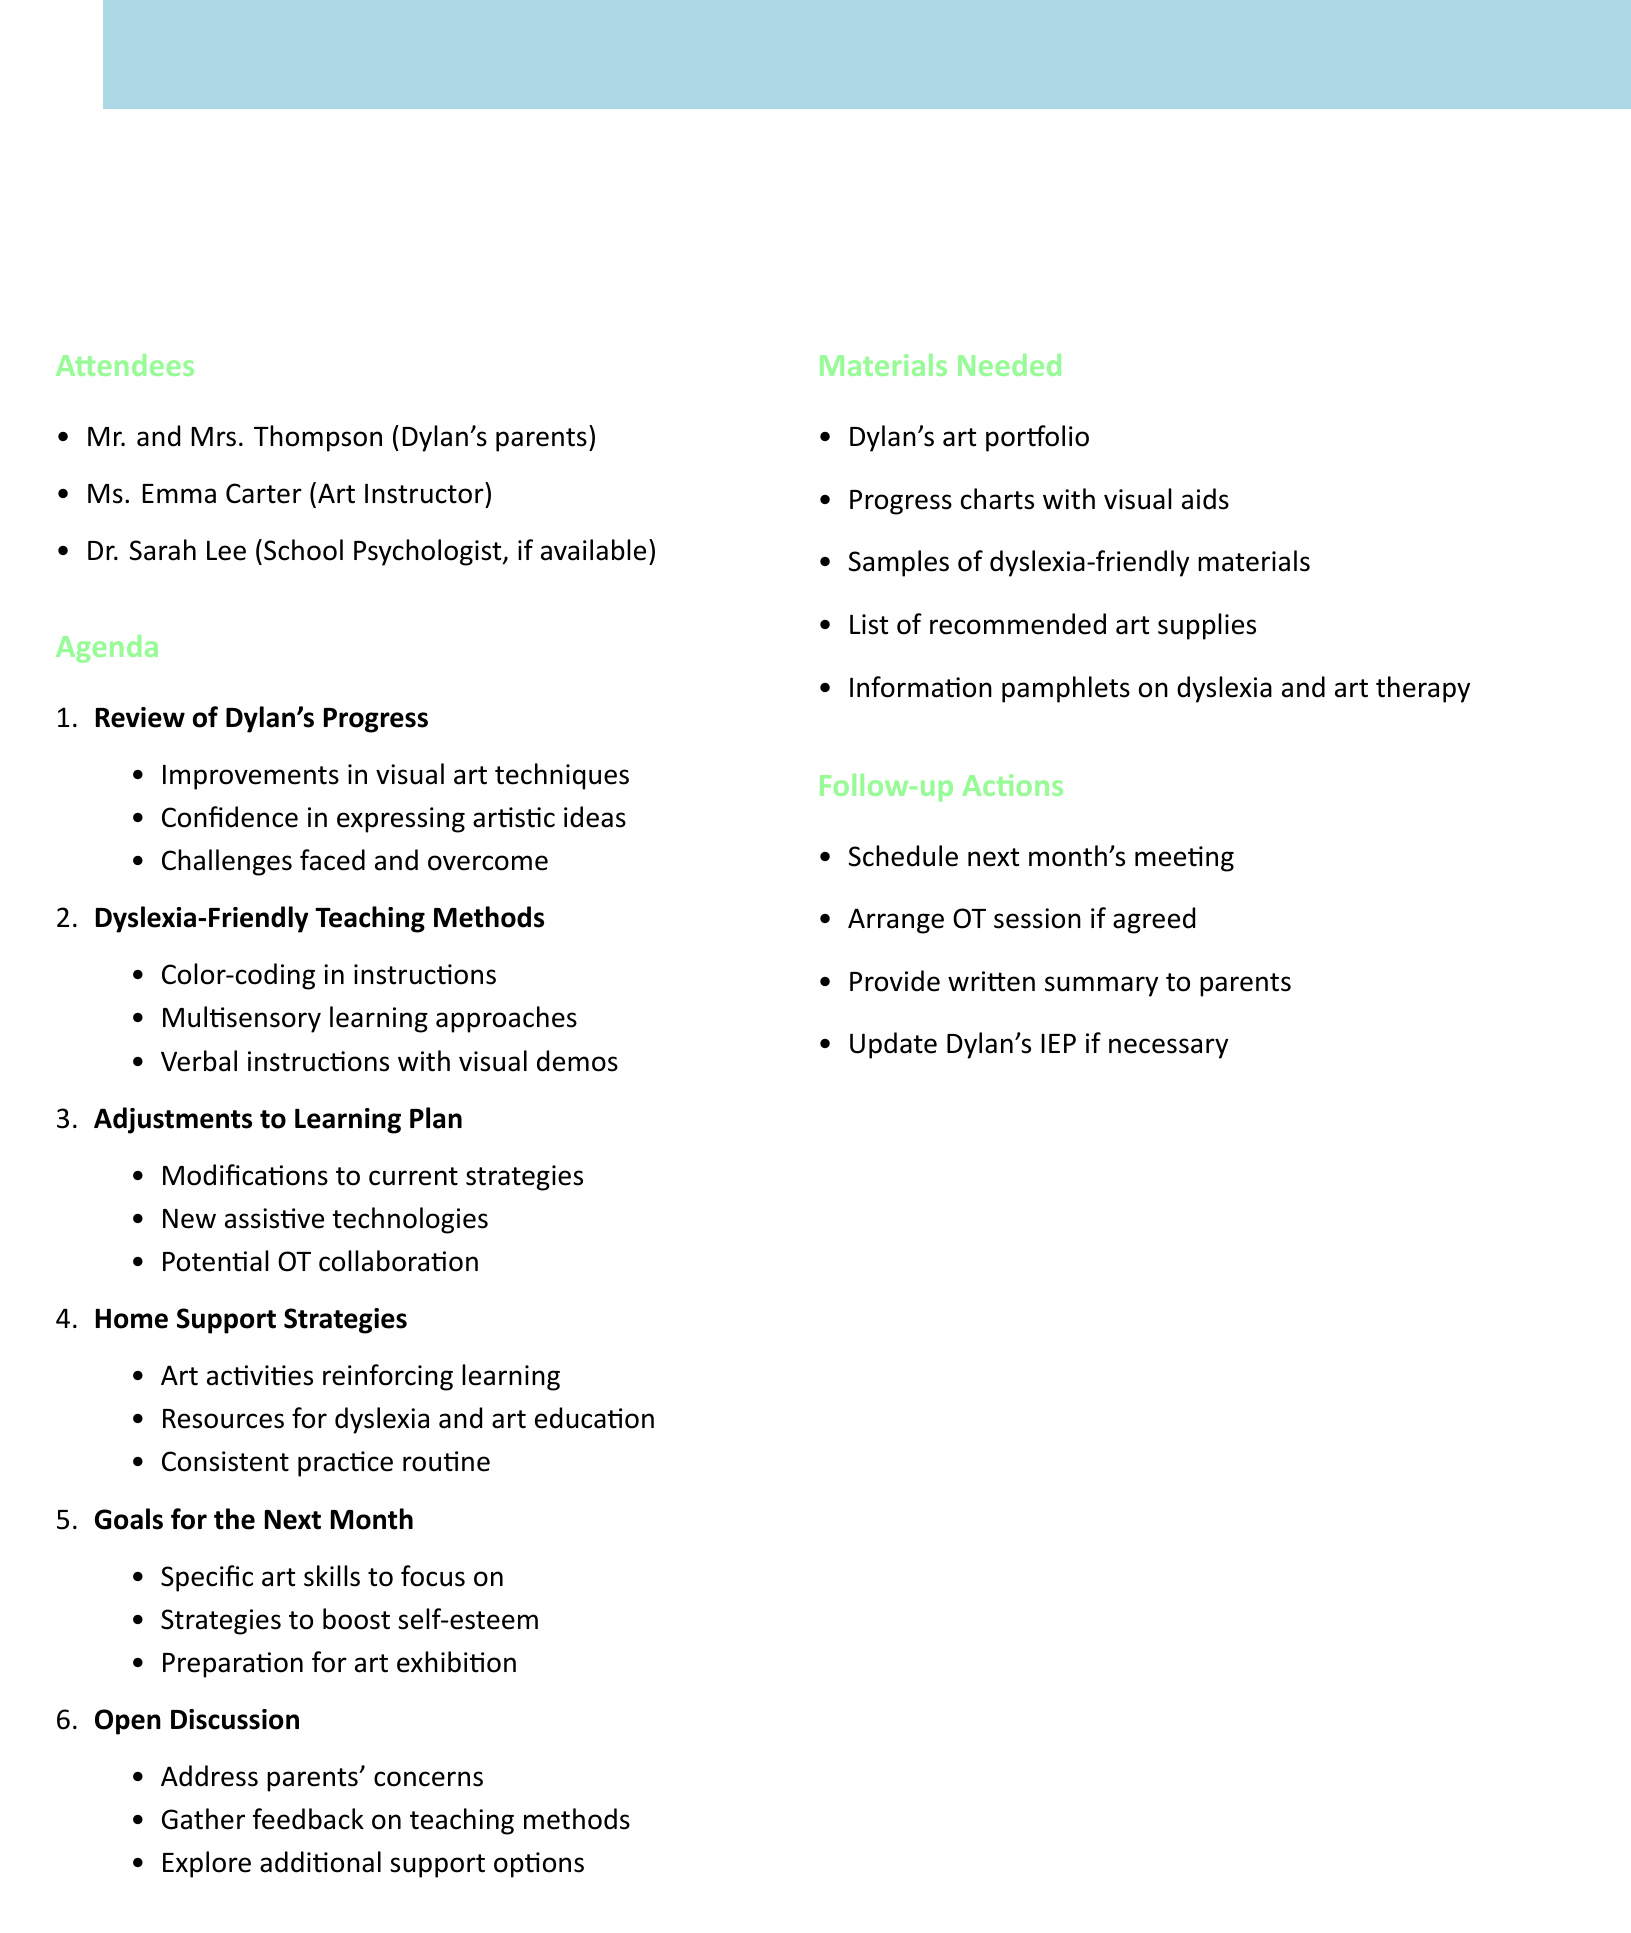What is the title of the meeting? The title of the meeting is provided at the top of the document as the main heading.
Answer: Monthly Progress Review: Individualized Learning Strategies for Dylan What is the date of the meeting? The date of the meeting is stated in the document as part of the meeting details.
Answer: May 15, 2023 Who are the attendees listed in the document? The attendees' names and roles are mentioned in a bullet list under the attendees section.
Answer: Mr. and Mrs. Thompson (Dylan's parents), Ms. Emma Carter (Art Instructor), Dr. Sarah Lee (School Psychologist, if available) What is one of the subtopics under "Review of Dylan's Progress"? The subtopics are listed to highlight specific areas of progress being discussed.
Answer: Improvements in visual art techniques Which teaching method is mentioned that supports dyslexia? The document includes specific teaching methods that are dyslexia-friendly, listed as part of a separate agenda item.
Answer: Use of color-coding in instructions What is one goal for the next month? The goals for the next month are identified in the agenda, focusing on Dylan's future learning targets.
Answer: Specific art skills to focus on What is included in the materials needed for the meeting? The materials needed are listed to prepare for the discussion during the meeting.
Answer: Dylan's art portfolio What action is proposed if agreed upon during the meeting? The follow-up actions suggest specific next steps that participants may decide upon during the meeting.
Answer: Arrange a session with occupational therapist if agreed upon 